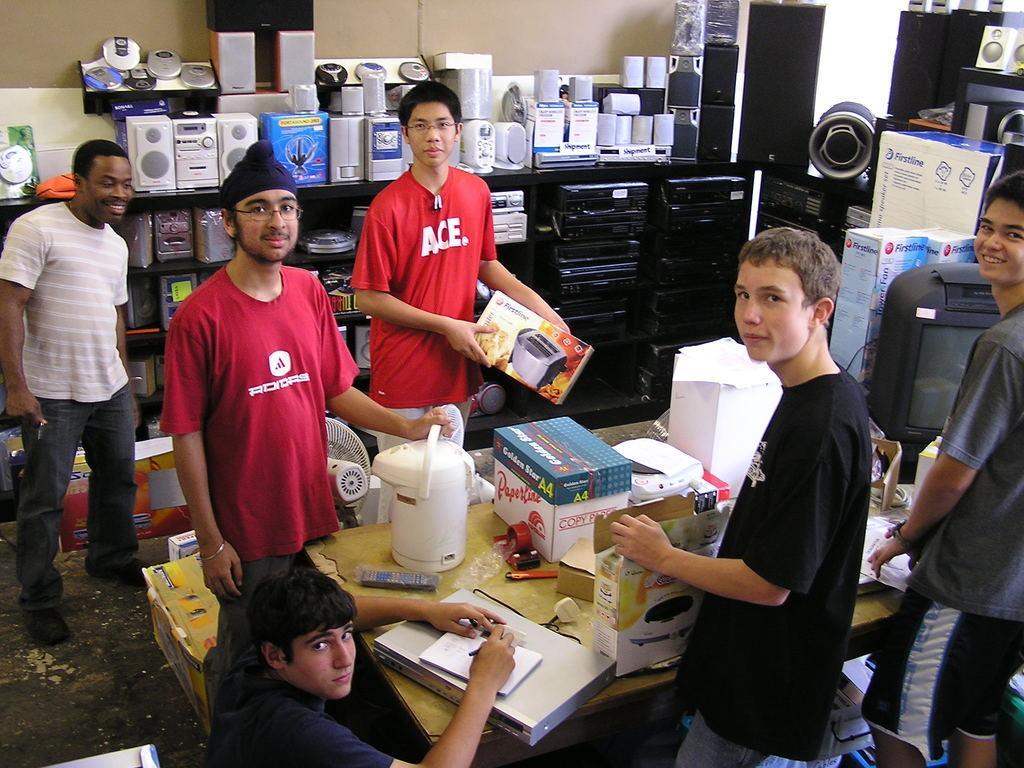Describe this image in one or two sentences. In this picture we can see few people, in front of them we can find few boxes, remote and other things on the table, in the background we can see speakers, musical systems and few boxes. 